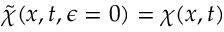<formula> <loc_0><loc_0><loc_500><loc_500>\tilde { \chi } ( x , t , \epsilon = 0 ) = \chi ( x , t )</formula> 